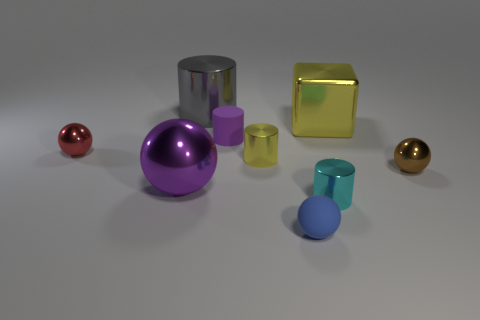There is a blue matte object that is to the right of the purple matte cylinder; is its size the same as the large gray object? No, the blue matte object is smaller in size compared to the large gray cylinder. The blue object is more similar in size to the small yellow cylinder next to it. 